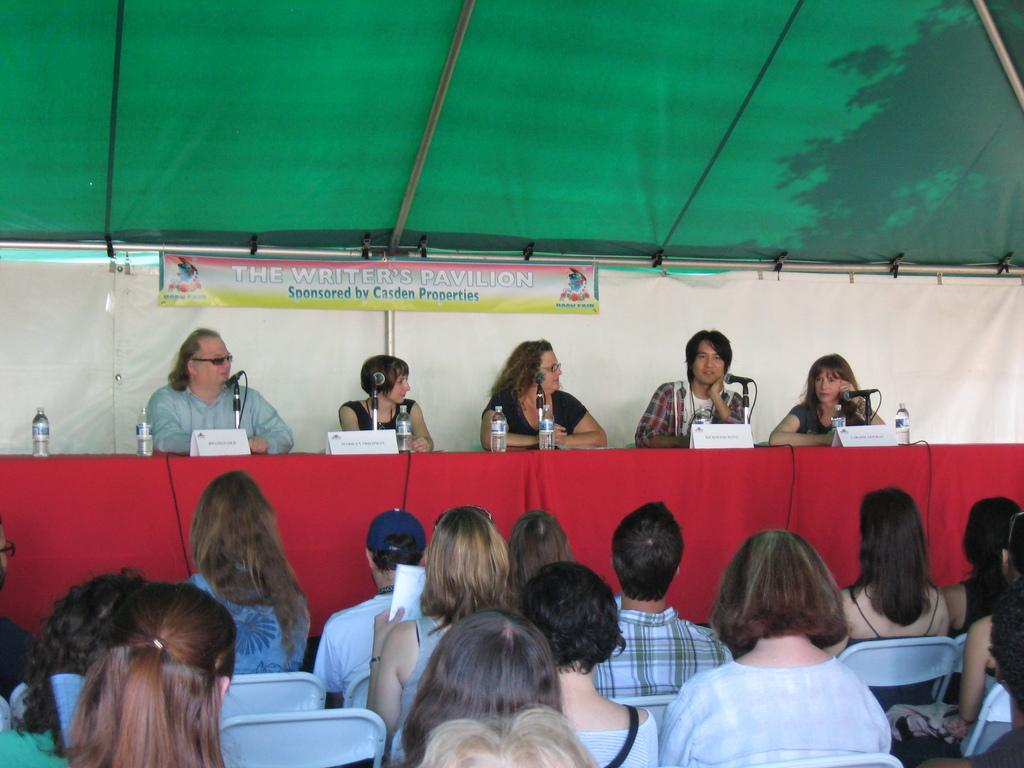Describe this image in one or two sentences. In this image we can see some group of persons sitting on chairs, in the background there are some persons sitting on chairs behind table on which there is red color cloth there are some microphones, water bottles and some name boards on table, there is white color sheet and green color tent. 